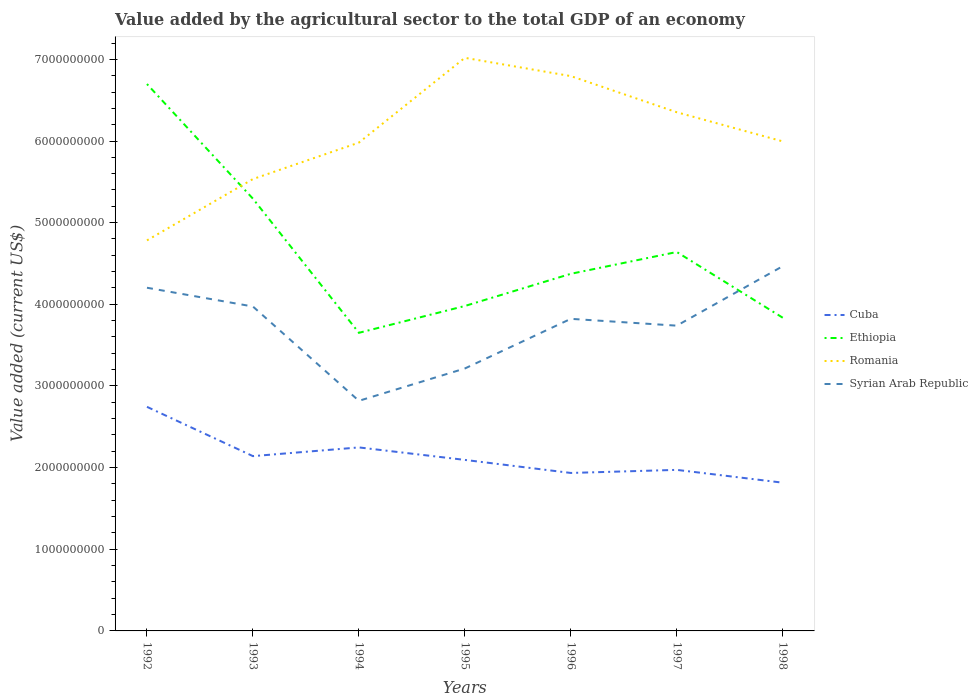How many different coloured lines are there?
Your answer should be compact. 4. Across all years, what is the maximum value added by the agricultural sector to the total GDP in Syrian Arab Republic?
Offer a terse response. 2.82e+09. In which year was the value added by the agricultural sector to the total GDP in Syrian Arab Republic maximum?
Make the answer very short. 1994. What is the total value added by the agricultural sector to the total GDP in Syrian Arab Republic in the graph?
Provide a succinct answer. -5.25e+08. What is the difference between the highest and the second highest value added by the agricultural sector to the total GDP in Syrian Arab Republic?
Provide a succinct answer. 1.65e+09. Is the value added by the agricultural sector to the total GDP in Ethiopia strictly greater than the value added by the agricultural sector to the total GDP in Romania over the years?
Provide a succinct answer. No. What is the difference between two consecutive major ticks on the Y-axis?
Ensure brevity in your answer.  1.00e+09. Does the graph contain grids?
Keep it short and to the point. No. Where does the legend appear in the graph?
Your answer should be compact. Center right. How are the legend labels stacked?
Give a very brief answer. Vertical. What is the title of the graph?
Make the answer very short. Value added by the agricultural sector to the total GDP of an economy. Does "Jamaica" appear as one of the legend labels in the graph?
Give a very brief answer. No. What is the label or title of the X-axis?
Your response must be concise. Years. What is the label or title of the Y-axis?
Ensure brevity in your answer.  Value added (current US$). What is the Value added (current US$) of Cuba in 1992?
Your answer should be very brief. 2.74e+09. What is the Value added (current US$) in Ethiopia in 1992?
Offer a very short reply. 6.70e+09. What is the Value added (current US$) of Romania in 1992?
Give a very brief answer. 4.78e+09. What is the Value added (current US$) in Syrian Arab Republic in 1992?
Give a very brief answer. 4.20e+09. What is the Value added (current US$) of Cuba in 1993?
Provide a short and direct response. 2.14e+09. What is the Value added (current US$) in Ethiopia in 1993?
Offer a terse response. 5.29e+09. What is the Value added (current US$) of Romania in 1993?
Keep it short and to the point. 5.53e+09. What is the Value added (current US$) of Syrian Arab Republic in 1993?
Provide a succinct answer. 3.97e+09. What is the Value added (current US$) of Cuba in 1994?
Offer a terse response. 2.25e+09. What is the Value added (current US$) of Ethiopia in 1994?
Provide a short and direct response. 3.65e+09. What is the Value added (current US$) in Romania in 1994?
Your response must be concise. 5.98e+09. What is the Value added (current US$) of Syrian Arab Republic in 1994?
Offer a very short reply. 2.82e+09. What is the Value added (current US$) in Cuba in 1995?
Your answer should be compact. 2.09e+09. What is the Value added (current US$) of Ethiopia in 1995?
Your answer should be compact. 3.98e+09. What is the Value added (current US$) of Romania in 1995?
Provide a succinct answer. 7.02e+09. What is the Value added (current US$) in Syrian Arab Republic in 1995?
Your response must be concise. 3.21e+09. What is the Value added (current US$) of Cuba in 1996?
Offer a terse response. 1.93e+09. What is the Value added (current US$) of Ethiopia in 1996?
Provide a succinct answer. 4.37e+09. What is the Value added (current US$) in Romania in 1996?
Offer a very short reply. 6.80e+09. What is the Value added (current US$) of Syrian Arab Republic in 1996?
Your answer should be very brief. 3.82e+09. What is the Value added (current US$) in Cuba in 1997?
Ensure brevity in your answer.  1.97e+09. What is the Value added (current US$) in Ethiopia in 1997?
Give a very brief answer. 4.64e+09. What is the Value added (current US$) in Romania in 1997?
Ensure brevity in your answer.  6.35e+09. What is the Value added (current US$) of Syrian Arab Republic in 1997?
Offer a terse response. 3.74e+09. What is the Value added (current US$) of Cuba in 1998?
Your answer should be very brief. 1.82e+09. What is the Value added (current US$) in Ethiopia in 1998?
Make the answer very short. 3.84e+09. What is the Value added (current US$) of Romania in 1998?
Provide a succinct answer. 6.00e+09. What is the Value added (current US$) of Syrian Arab Republic in 1998?
Ensure brevity in your answer.  4.47e+09. Across all years, what is the maximum Value added (current US$) of Cuba?
Provide a short and direct response. 2.74e+09. Across all years, what is the maximum Value added (current US$) in Ethiopia?
Give a very brief answer. 6.70e+09. Across all years, what is the maximum Value added (current US$) in Romania?
Provide a succinct answer. 7.02e+09. Across all years, what is the maximum Value added (current US$) of Syrian Arab Republic?
Make the answer very short. 4.47e+09. Across all years, what is the minimum Value added (current US$) in Cuba?
Your answer should be compact. 1.82e+09. Across all years, what is the minimum Value added (current US$) of Ethiopia?
Ensure brevity in your answer.  3.65e+09. Across all years, what is the minimum Value added (current US$) of Romania?
Make the answer very short. 4.78e+09. Across all years, what is the minimum Value added (current US$) in Syrian Arab Republic?
Give a very brief answer. 2.82e+09. What is the total Value added (current US$) in Cuba in the graph?
Provide a succinct answer. 1.49e+1. What is the total Value added (current US$) of Ethiopia in the graph?
Make the answer very short. 3.25e+1. What is the total Value added (current US$) in Romania in the graph?
Your answer should be very brief. 4.25e+1. What is the total Value added (current US$) of Syrian Arab Republic in the graph?
Your answer should be compact. 2.62e+1. What is the difference between the Value added (current US$) of Cuba in 1992 and that in 1993?
Provide a succinct answer. 6.04e+08. What is the difference between the Value added (current US$) of Ethiopia in 1992 and that in 1993?
Give a very brief answer. 1.40e+09. What is the difference between the Value added (current US$) in Romania in 1992 and that in 1993?
Give a very brief answer. -7.51e+08. What is the difference between the Value added (current US$) in Syrian Arab Republic in 1992 and that in 1993?
Offer a very short reply. 2.30e+08. What is the difference between the Value added (current US$) in Cuba in 1992 and that in 1994?
Keep it short and to the point. 4.97e+08. What is the difference between the Value added (current US$) of Ethiopia in 1992 and that in 1994?
Provide a short and direct response. 3.05e+09. What is the difference between the Value added (current US$) of Romania in 1992 and that in 1994?
Give a very brief answer. -1.20e+09. What is the difference between the Value added (current US$) in Syrian Arab Republic in 1992 and that in 1994?
Provide a short and direct response. 1.38e+09. What is the difference between the Value added (current US$) in Cuba in 1992 and that in 1995?
Provide a succinct answer. 6.50e+08. What is the difference between the Value added (current US$) of Ethiopia in 1992 and that in 1995?
Your response must be concise. 2.72e+09. What is the difference between the Value added (current US$) in Romania in 1992 and that in 1995?
Keep it short and to the point. -2.24e+09. What is the difference between the Value added (current US$) in Syrian Arab Republic in 1992 and that in 1995?
Provide a short and direct response. 9.89e+08. What is the difference between the Value added (current US$) in Cuba in 1992 and that in 1996?
Provide a succinct answer. 8.10e+08. What is the difference between the Value added (current US$) in Ethiopia in 1992 and that in 1996?
Your answer should be compact. 2.32e+09. What is the difference between the Value added (current US$) of Romania in 1992 and that in 1996?
Give a very brief answer. -2.01e+09. What is the difference between the Value added (current US$) in Syrian Arab Republic in 1992 and that in 1996?
Your response must be concise. 3.81e+08. What is the difference between the Value added (current US$) in Cuba in 1992 and that in 1997?
Your answer should be very brief. 7.72e+08. What is the difference between the Value added (current US$) of Ethiopia in 1992 and that in 1997?
Provide a short and direct response. 2.06e+09. What is the difference between the Value added (current US$) of Romania in 1992 and that in 1997?
Your response must be concise. -1.57e+09. What is the difference between the Value added (current US$) of Syrian Arab Republic in 1992 and that in 1997?
Offer a very short reply. 4.64e+08. What is the difference between the Value added (current US$) of Cuba in 1992 and that in 1998?
Keep it short and to the point. 9.29e+08. What is the difference between the Value added (current US$) of Ethiopia in 1992 and that in 1998?
Ensure brevity in your answer.  2.86e+09. What is the difference between the Value added (current US$) of Romania in 1992 and that in 1998?
Provide a succinct answer. -1.21e+09. What is the difference between the Value added (current US$) of Syrian Arab Republic in 1992 and that in 1998?
Keep it short and to the point. -2.64e+08. What is the difference between the Value added (current US$) of Cuba in 1993 and that in 1994?
Provide a succinct answer. -1.07e+08. What is the difference between the Value added (current US$) of Ethiopia in 1993 and that in 1994?
Offer a terse response. 1.64e+09. What is the difference between the Value added (current US$) of Romania in 1993 and that in 1994?
Provide a short and direct response. -4.46e+08. What is the difference between the Value added (current US$) of Syrian Arab Republic in 1993 and that in 1994?
Keep it short and to the point. 1.15e+09. What is the difference between the Value added (current US$) in Cuba in 1993 and that in 1995?
Ensure brevity in your answer.  4.63e+07. What is the difference between the Value added (current US$) in Ethiopia in 1993 and that in 1995?
Offer a terse response. 1.31e+09. What is the difference between the Value added (current US$) in Romania in 1993 and that in 1995?
Your answer should be very brief. -1.48e+09. What is the difference between the Value added (current US$) in Syrian Arab Republic in 1993 and that in 1995?
Ensure brevity in your answer.  7.59e+08. What is the difference between the Value added (current US$) of Cuba in 1993 and that in 1996?
Give a very brief answer. 2.06e+08. What is the difference between the Value added (current US$) of Ethiopia in 1993 and that in 1996?
Provide a succinct answer. 9.20e+08. What is the difference between the Value added (current US$) in Romania in 1993 and that in 1996?
Offer a very short reply. -1.26e+09. What is the difference between the Value added (current US$) in Syrian Arab Republic in 1993 and that in 1996?
Make the answer very short. 1.51e+08. What is the difference between the Value added (current US$) in Cuba in 1993 and that in 1997?
Make the answer very short. 1.68e+08. What is the difference between the Value added (current US$) in Ethiopia in 1993 and that in 1997?
Make the answer very short. 6.53e+08. What is the difference between the Value added (current US$) of Romania in 1993 and that in 1997?
Make the answer very short. -8.18e+08. What is the difference between the Value added (current US$) of Syrian Arab Republic in 1993 and that in 1997?
Your answer should be compact. 2.34e+08. What is the difference between the Value added (current US$) of Cuba in 1993 and that in 1998?
Your response must be concise. 3.25e+08. What is the difference between the Value added (current US$) of Ethiopia in 1993 and that in 1998?
Offer a terse response. 1.46e+09. What is the difference between the Value added (current US$) of Romania in 1993 and that in 1998?
Offer a terse response. -4.61e+08. What is the difference between the Value added (current US$) of Syrian Arab Republic in 1993 and that in 1998?
Make the answer very short. -4.94e+08. What is the difference between the Value added (current US$) in Cuba in 1994 and that in 1995?
Keep it short and to the point. 1.53e+08. What is the difference between the Value added (current US$) in Ethiopia in 1994 and that in 1995?
Give a very brief answer. -3.29e+08. What is the difference between the Value added (current US$) in Romania in 1994 and that in 1995?
Offer a very short reply. -1.04e+09. What is the difference between the Value added (current US$) in Syrian Arab Republic in 1994 and that in 1995?
Make the answer very short. -3.96e+08. What is the difference between the Value added (current US$) in Cuba in 1994 and that in 1996?
Keep it short and to the point. 3.13e+08. What is the difference between the Value added (current US$) of Ethiopia in 1994 and that in 1996?
Your response must be concise. -7.23e+08. What is the difference between the Value added (current US$) in Romania in 1994 and that in 1996?
Offer a terse response. -8.15e+08. What is the difference between the Value added (current US$) of Syrian Arab Republic in 1994 and that in 1996?
Make the answer very short. -1.00e+09. What is the difference between the Value added (current US$) in Cuba in 1994 and that in 1997?
Your answer should be very brief. 2.75e+08. What is the difference between the Value added (current US$) in Ethiopia in 1994 and that in 1997?
Your answer should be very brief. -9.90e+08. What is the difference between the Value added (current US$) in Romania in 1994 and that in 1997?
Offer a terse response. -3.72e+08. What is the difference between the Value added (current US$) in Syrian Arab Republic in 1994 and that in 1997?
Offer a terse response. -9.20e+08. What is the difference between the Value added (current US$) in Cuba in 1994 and that in 1998?
Your answer should be very brief. 4.32e+08. What is the difference between the Value added (current US$) in Ethiopia in 1994 and that in 1998?
Your answer should be very brief. -1.85e+08. What is the difference between the Value added (current US$) in Romania in 1994 and that in 1998?
Ensure brevity in your answer.  -1.50e+07. What is the difference between the Value added (current US$) of Syrian Arab Republic in 1994 and that in 1998?
Offer a terse response. -1.65e+09. What is the difference between the Value added (current US$) of Cuba in 1995 and that in 1996?
Your answer should be compact. 1.60e+08. What is the difference between the Value added (current US$) in Ethiopia in 1995 and that in 1996?
Keep it short and to the point. -3.94e+08. What is the difference between the Value added (current US$) of Romania in 1995 and that in 1996?
Your answer should be very brief. 2.24e+08. What is the difference between the Value added (current US$) of Syrian Arab Republic in 1995 and that in 1996?
Offer a terse response. -6.08e+08. What is the difference between the Value added (current US$) of Cuba in 1995 and that in 1997?
Your answer should be very brief. 1.22e+08. What is the difference between the Value added (current US$) of Ethiopia in 1995 and that in 1997?
Offer a terse response. -6.61e+08. What is the difference between the Value added (current US$) of Romania in 1995 and that in 1997?
Provide a short and direct response. 6.67e+08. What is the difference between the Value added (current US$) of Syrian Arab Republic in 1995 and that in 1997?
Give a very brief answer. -5.25e+08. What is the difference between the Value added (current US$) in Cuba in 1995 and that in 1998?
Make the answer very short. 2.79e+08. What is the difference between the Value added (current US$) in Ethiopia in 1995 and that in 1998?
Your response must be concise. 1.44e+08. What is the difference between the Value added (current US$) of Romania in 1995 and that in 1998?
Ensure brevity in your answer.  1.02e+09. What is the difference between the Value added (current US$) in Syrian Arab Republic in 1995 and that in 1998?
Your answer should be very brief. -1.25e+09. What is the difference between the Value added (current US$) in Cuba in 1996 and that in 1997?
Ensure brevity in your answer.  -3.78e+07. What is the difference between the Value added (current US$) of Ethiopia in 1996 and that in 1997?
Offer a very short reply. -2.67e+08. What is the difference between the Value added (current US$) in Romania in 1996 and that in 1997?
Keep it short and to the point. 4.43e+08. What is the difference between the Value added (current US$) of Syrian Arab Republic in 1996 and that in 1997?
Your answer should be very brief. 8.35e+07. What is the difference between the Value added (current US$) in Cuba in 1996 and that in 1998?
Offer a terse response. 1.19e+08. What is the difference between the Value added (current US$) in Ethiopia in 1996 and that in 1998?
Your response must be concise. 5.38e+08. What is the difference between the Value added (current US$) in Romania in 1996 and that in 1998?
Your answer should be very brief. 8.00e+08. What is the difference between the Value added (current US$) of Syrian Arab Republic in 1996 and that in 1998?
Give a very brief answer. -6.45e+08. What is the difference between the Value added (current US$) in Cuba in 1997 and that in 1998?
Your answer should be compact. 1.57e+08. What is the difference between the Value added (current US$) of Ethiopia in 1997 and that in 1998?
Give a very brief answer. 8.05e+08. What is the difference between the Value added (current US$) of Romania in 1997 and that in 1998?
Keep it short and to the point. 3.57e+08. What is the difference between the Value added (current US$) in Syrian Arab Republic in 1997 and that in 1998?
Provide a short and direct response. -7.28e+08. What is the difference between the Value added (current US$) in Cuba in 1992 and the Value added (current US$) in Ethiopia in 1993?
Your answer should be compact. -2.55e+09. What is the difference between the Value added (current US$) in Cuba in 1992 and the Value added (current US$) in Romania in 1993?
Provide a short and direct response. -2.79e+09. What is the difference between the Value added (current US$) in Cuba in 1992 and the Value added (current US$) in Syrian Arab Republic in 1993?
Ensure brevity in your answer.  -1.23e+09. What is the difference between the Value added (current US$) in Ethiopia in 1992 and the Value added (current US$) in Romania in 1993?
Your response must be concise. 1.16e+09. What is the difference between the Value added (current US$) of Ethiopia in 1992 and the Value added (current US$) of Syrian Arab Republic in 1993?
Offer a very short reply. 2.72e+09. What is the difference between the Value added (current US$) in Romania in 1992 and the Value added (current US$) in Syrian Arab Republic in 1993?
Offer a very short reply. 8.10e+08. What is the difference between the Value added (current US$) in Cuba in 1992 and the Value added (current US$) in Ethiopia in 1994?
Offer a terse response. -9.06e+08. What is the difference between the Value added (current US$) in Cuba in 1992 and the Value added (current US$) in Romania in 1994?
Your response must be concise. -3.24e+09. What is the difference between the Value added (current US$) in Cuba in 1992 and the Value added (current US$) in Syrian Arab Republic in 1994?
Your answer should be very brief. -7.36e+07. What is the difference between the Value added (current US$) of Ethiopia in 1992 and the Value added (current US$) of Romania in 1994?
Provide a short and direct response. 7.17e+08. What is the difference between the Value added (current US$) in Ethiopia in 1992 and the Value added (current US$) in Syrian Arab Republic in 1994?
Keep it short and to the point. 3.88e+09. What is the difference between the Value added (current US$) of Romania in 1992 and the Value added (current US$) of Syrian Arab Republic in 1994?
Your answer should be compact. 1.96e+09. What is the difference between the Value added (current US$) in Cuba in 1992 and the Value added (current US$) in Ethiopia in 1995?
Provide a short and direct response. -1.23e+09. What is the difference between the Value added (current US$) in Cuba in 1992 and the Value added (current US$) in Romania in 1995?
Provide a succinct answer. -4.27e+09. What is the difference between the Value added (current US$) in Cuba in 1992 and the Value added (current US$) in Syrian Arab Republic in 1995?
Ensure brevity in your answer.  -4.70e+08. What is the difference between the Value added (current US$) of Ethiopia in 1992 and the Value added (current US$) of Romania in 1995?
Offer a terse response. -3.21e+08. What is the difference between the Value added (current US$) of Ethiopia in 1992 and the Value added (current US$) of Syrian Arab Republic in 1995?
Your answer should be very brief. 3.48e+09. What is the difference between the Value added (current US$) in Romania in 1992 and the Value added (current US$) in Syrian Arab Republic in 1995?
Provide a succinct answer. 1.57e+09. What is the difference between the Value added (current US$) in Cuba in 1992 and the Value added (current US$) in Ethiopia in 1996?
Keep it short and to the point. -1.63e+09. What is the difference between the Value added (current US$) in Cuba in 1992 and the Value added (current US$) in Romania in 1996?
Give a very brief answer. -4.05e+09. What is the difference between the Value added (current US$) in Cuba in 1992 and the Value added (current US$) in Syrian Arab Republic in 1996?
Give a very brief answer. -1.08e+09. What is the difference between the Value added (current US$) of Ethiopia in 1992 and the Value added (current US$) of Romania in 1996?
Your answer should be very brief. -9.73e+07. What is the difference between the Value added (current US$) of Ethiopia in 1992 and the Value added (current US$) of Syrian Arab Republic in 1996?
Your answer should be compact. 2.88e+09. What is the difference between the Value added (current US$) of Romania in 1992 and the Value added (current US$) of Syrian Arab Republic in 1996?
Your answer should be very brief. 9.61e+08. What is the difference between the Value added (current US$) in Cuba in 1992 and the Value added (current US$) in Ethiopia in 1997?
Keep it short and to the point. -1.90e+09. What is the difference between the Value added (current US$) in Cuba in 1992 and the Value added (current US$) in Romania in 1997?
Your answer should be very brief. -3.61e+09. What is the difference between the Value added (current US$) of Cuba in 1992 and the Value added (current US$) of Syrian Arab Republic in 1997?
Offer a terse response. -9.94e+08. What is the difference between the Value added (current US$) of Ethiopia in 1992 and the Value added (current US$) of Romania in 1997?
Your response must be concise. 3.46e+08. What is the difference between the Value added (current US$) in Ethiopia in 1992 and the Value added (current US$) in Syrian Arab Republic in 1997?
Make the answer very short. 2.96e+09. What is the difference between the Value added (current US$) of Romania in 1992 and the Value added (current US$) of Syrian Arab Republic in 1997?
Give a very brief answer. 1.04e+09. What is the difference between the Value added (current US$) in Cuba in 1992 and the Value added (current US$) in Ethiopia in 1998?
Provide a succinct answer. -1.09e+09. What is the difference between the Value added (current US$) in Cuba in 1992 and the Value added (current US$) in Romania in 1998?
Offer a terse response. -3.25e+09. What is the difference between the Value added (current US$) of Cuba in 1992 and the Value added (current US$) of Syrian Arab Republic in 1998?
Keep it short and to the point. -1.72e+09. What is the difference between the Value added (current US$) of Ethiopia in 1992 and the Value added (current US$) of Romania in 1998?
Your response must be concise. 7.02e+08. What is the difference between the Value added (current US$) of Ethiopia in 1992 and the Value added (current US$) of Syrian Arab Republic in 1998?
Make the answer very short. 2.23e+09. What is the difference between the Value added (current US$) in Romania in 1992 and the Value added (current US$) in Syrian Arab Republic in 1998?
Ensure brevity in your answer.  3.16e+08. What is the difference between the Value added (current US$) in Cuba in 1993 and the Value added (current US$) in Ethiopia in 1994?
Offer a very short reply. -1.51e+09. What is the difference between the Value added (current US$) of Cuba in 1993 and the Value added (current US$) of Romania in 1994?
Give a very brief answer. -3.84e+09. What is the difference between the Value added (current US$) in Cuba in 1993 and the Value added (current US$) in Syrian Arab Republic in 1994?
Make the answer very short. -6.77e+08. What is the difference between the Value added (current US$) of Ethiopia in 1993 and the Value added (current US$) of Romania in 1994?
Provide a short and direct response. -6.87e+08. What is the difference between the Value added (current US$) of Ethiopia in 1993 and the Value added (current US$) of Syrian Arab Republic in 1994?
Your answer should be very brief. 2.48e+09. What is the difference between the Value added (current US$) in Romania in 1993 and the Value added (current US$) in Syrian Arab Republic in 1994?
Give a very brief answer. 2.72e+09. What is the difference between the Value added (current US$) in Cuba in 1993 and the Value added (current US$) in Ethiopia in 1995?
Your answer should be very brief. -1.84e+09. What is the difference between the Value added (current US$) in Cuba in 1993 and the Value added (current US$) in Romania in 1995?
Give a very brief answer. -4.88e+09. What is the difference between the Value added (current US$) in Cuba in 1993 and the Value added (current US$) in Syrian Arab Republic in 1995?
Give a very brief answer. -1.07e+09. What is the difference between the Value added (current US$) in Ethiopia in 1993 and the Value added (current US$) in Romania in 1995?
Your response must be concise. -1.73e+09. What is the difference between the Value added (current US$) of Ethiopia in 1993 and the Value added (current US$) of Syrian Arab Republic in 1995?
Provide a short and direct response. 2.08e+09. What is the difference between the Value added (current US$) in Romania in 1993 and the Value added (current US$) in Syrian Arab Republic in 1995?
Your response must be concise. 2.32e+09. What is the difference between the Value added (current US$) in Cuba in 1993 and the Value added (current US$) in Ethiopia in 1996?
Your response must be concise. -2.23e+09. What is the difference between the Value added (current US$) in Cuba in 1993 and the Value added (current US$) in Romania in 1996?
Offer a very short reply. -4.65e+09. What is the difference between the Value added (current US$) in Cuba in 1993 and the Value added (current US$) in Syrian Arab Republic in 1996?
Give a very brief answer. -1.68e+09. What is the difference between the Value added (current US$) of Ethiopia in 1993 and the Value added (current US$) of Romania in 1996?
Your answer should be very brief. -1.50e+09. What is the difference between the Value added (current US$) of Ethiopia in 1993 and the Value added (current US$) of Syrian Arab Republic in 1996?
Provide a succinct answer. 1.47e+09. What is the difference between the Value added (current US$) in Romania in 1993 and the Value added (current US$) in Syrian Arab Republic in 1996?
Keep it short and to the point. 1.71e+09. What is the difference between the Value added (current US$) of Cuba in 1993 and the Value added (current US$) of Ethiopia in 1997?
Your response must be concise. -2.50e+09. What is the difference between the Value added (current US$) in Cuba in 1993 and the Value added (current US$) in Romania in 1997?
Your response must be concise. -4.21e+09. What is the difference between the Value added (current US$) of Cuba in 1993 and the Value added (current US$) of Syrian Arab Republic in 1997?
Make the answer very short. -1.60e+09. What is the difference between the Value added (current US$) in Ethiopia in 1993 and the Value added (current US$) in Romania in 1997?
Ensure brevity in your answer.  -1.06e+09. What is the difference between the Value added (current US$) in Ethiopia in 1993 and the Value added (current US$) in Syrian Arab Republic in 1997?
Your response must be concise. 1.56e+09. What is the difference between the Value added (current US$) of Romania in 1993 and the Value added (current US$) of Syrian Arab Republic in 1997?
Your response must be concise. 1.80e+09. What is the difference between the Value added (current US$) in Cuba in 1993 and the Value added (current US$) in Ethiopia in 1998?
Ensure brevity in your answer.  -1.69e+09. What is the difference between the Value added (current US$) of Cuba in 1993 and the Value added (current US$) of Romania in 1998?
Provide a short and direct response. -3.85e+09. What is the difference between the Value added (current US$) of Cuba in 1993 and the Value added (current US$) of Syrian Arab Republic in 1998?
Your answer should be very brief. -2.33e+09. What is the difference between the Value added (current US$) of Ethiopia in 1993 and the Value added (current US$) of Romania in 1998?
Make the answer very short. -7.02e+08. What is the difference between the Value added (current US$) in Ethiopia in 1993 and the Value added (current US$) in Syrian Arab Republic in 1998?
Keep it short and to the point. 8.27e+08. What is the difference between the Value added (current US$) of Romania in 1993 and the Value added (current US$) of Syrian Arab Republic in 1998?
Your answer should be very brief. 1.07e+09. What is the difference between the Value added (current US$) of Cuba in 1994 and the Value added (current US$) of Ethiopia in 1995?
Your answer should be compact. -1.73e+09. What is the difference between the Value added (current US$) of Cuba in 1994 and the Value added (current US$) of Romania in 1995?
Make the answer very short. -4.77e+09. What is the difference between the Value added (current US$) of Cuba in 1994 and the Value added (current US$) of Syrian Arab Republic in 1995?
Your answer should be compact. -9.67e+08. What is the difference between the Value added (current US$) of Ethiopia in 1994 and the Value added (current US$) of Romania in 1995?
Offer a terse response. -3.37e+09. What is the difference between the Value added (current US$) of Ethiopia in 1994 and the Value added (current US$) of Syrian Arab Republic in 1995?
Provide a short and direct response. 4.37e+08. What is the difference between the Value added (current US$) in Romania in 1994 and the Value added (current US$) in Syrian Arab Republic in 1995?
Make the answer very short. 2.77e+09. What is the difference between the Value added (current US$) of Cuba in 1994 and the Value added (current US$) of Ethiopia in 1996?
Provide a succinct answer. -2.13e+09. What is the difference between the Value added (current US$) in Cuba in 1994 and the Value added (current US$) in Romania in 1996?
Your answer should be compact. -4.55e+09. What is the difference between the Value added (current US$) in Cuba in 1994 and the Value added (current US$) in Syrian Arab Republic in 1996?
Keep it short and to the point. -1.57e+09. What is the difference between the Value added (current US$) in Ethiopia in 1994 and the Value added (current US$) in Romania in 1996?
Your response must be concise. -3.14e+09. What is the difference between the Value added (current US$) in Ethiopia in 1994 and the Value added (current US$) in Syrian Arab Republic in 1996?
Keep it short and to the point. -1.71e+08. What is the difference between the Value added (current US$) of Romania in 1994 and the Value added (current US$) of Syrian Arab Republic in 1996?
Your answer should be compact. 2.16e+09. What is the difference between the Value added (current US$) of Cuba in 1994 and the Value added (current US$) of Ethiopia in 1997?
Provide a short and direct response. -2.39e+09. What is the difference between the Value added (current US$) of Cuba in 1994 and the Value added (current US$) of Romania in 1997?
Provide a succinct answer. -4.10e+09. What is the difference between the Value added (current US$) of Cuba in 1994 and the Value added (current US$) of Syrian Arab Republic in 1997?
Your answer should be very brief. -1.49e+09. What is the difference between the Value added (current US$) in Ethiopia in 1994 and the Value added (current US$) in Romania in 1997?
Ensure brevity in your answer.  -2.70e+09. What is the difference between the Value added (current US$) of Ethiopia in 1994 and the Value added (current US$) of Syrian Arab Republic in 1997?
Give a very brief answer. -8.76e+07. What is the difference between the Value added (current US$) in Romania in 1994 and the Value added (current US$) in Syrian Arab Republic in 1997?
Your response must be concise. 2.24e+09. What is the difference between the Value added (current US$) in Cuba in 1994 and the Value added (current US$) in Ethiopia in 1998?
Offer a very short reply. -1.59e+09. What is the difference between the Value added (current US$) in Cuba in 1994 and the Value added (current US$) in Romania in 1998?
Offer a terse response. -3.75e+09. What is the difference between the Value added (current US$) of Cuba in 1994 and the Value added (current US$) of Syrian Arab Republic in 1998?
Offer a very short reply. -2.22e+09. What is the difference between the Value added (current US$) in Ethiopia in 1994 and the Value added (current US$) in Romania in 1998?
Provide a succinct answer. -2.34e+09. What is the difference between the Value added (current US$) of Ethiopia in 1994 and the Value added (current US$) of Syrian Arab Republic in 1998?
Make the answer very short. -8.16e+08. What is the difference between the Value added (current US$) in Romania in 1994 and the Value added (current US$) in Syrian Arab Republic in 1998?
Ensure brevity in your answer.  1.51e+09. What is the difference between the Value added (current US$) of Cuba in 1995 and the Value added (current US$) of Ethiopia in 1996?
Ensure brevity in your answer.  -2.28e+09. What is the difference between the Value added (current US$) of Cuba in 1995 and the Value added (current US$) of Romania in 1996?
Your answer should be very brief. -4.70e+09. What is the difference between the Value added (current US$) of Cuba in 1995 and the Value added (current US$) of Syrian Arab Republic in 1996?
Your response must be concise. -1.73e+09. What is the difference between the Value added (current US$) of Ethiopia in 1995 and the Value added (current US$) of Romania in 1996?
Give a very brief answer. -2.82e+09. What is the difference between the Value added (current US$) in Ethiopia in 1995 and the Value added (current US$) in Syrian Arab Republic in 1996?
Give a very brief answer. 1.57e+08. What is the difference between the Value added (current US$) in Romania in 1995 and the Value added (current US$) in Syrian Arab Republic in 1996?
Keep it short and to the point. 3.20e+09. What is the difference between the Value added (current US$) in Cuba in 1995 and the Value added (current US$) in Ethiopia in 1997?
Offer a terse response. -2.55e+09. What is the difference between the Value added (current US$) in Cuba in 1995 and the Value added (current US$) in Romania in 1997?
Keep it short and to the point. -4.26e+09. What is the difference between the Value added (current US$) of Cuba in 1995 and the Value added (current US$) of Syrian Arab Republic in 1997?
Ensure brevity in your answer.  -1.64e+09. What is the difference between the Value added (current US$) in Ethiopia in 1995 and the Value added (current US$) in Romania in 1997?
Your response must be concise. -2.37e+09. What is the difference between the Value added (current US$) in Ethiopia in 1995 and the Value added (current US$) in Syrian Arab Republic in 1997?
Your answer should be very brief. 2.41e+08. What is the difference between the Value added (current US$) in Romania in 1995 and the Value added (current US$) in Syrian Arab Republic in 1997?
Provide a succinct answer. 3.28e+09. What is the difference between the Value added (current US$) in Cuba in 1995 and the Value added (current US$) in Ethiopia in 1998?
Keep it short and to the point. -1.74e+09. What is the difference between the Value added (current US$) of Cuba in 1995 and the Value added (current US$) of Romania in 1998?
Keep it short and to the point. -3.90e+09. What is the difference between the Value added (current US$) in Cuba in 1995 and the Value added (current US$) in Syrian Arab Republic in 1998?
Keep it short and to the point. -2.37e+09. What is the difference between the Value added (current US$) of Ethiopia in 1995 and the Value added (current US$) of Romania in 1998?
Keep it short and to the point. -2.02e+09. What is the difference between the Value added (current US$) in Ethiopia in 1995 and the Value added (current US$) in Syrian Arab Republic in 1998?
Give a very brief answer. -4.87e+08. What is the difference between the Value added (current US$) of Romania in 1995 and the Value added (current US$) of Syrian Arab Republic in 1998?
Ensure brevity in your answer.  2.55e+09. What is the difference between the Value added (current US$) in Cuba in 1996 and the Value added (current US$) in Ethiopia in 1997?
Give a very brief answer. -2.71e+09. What is the difference between the Value added (current US$) of Cuba in 1996 and the Value added (current US$) of Romania in 1997?
Give a very brief answer. -4.42e+09. What is the difference between the Value added (current US$) of Cuba in 1996 and the Value added (current US$) of Syrian Arab Republic in 1997?
Offer a terse response. -1.80e+09. What is the difference between the Value added (current US$) in Ethiopia in 1996 and the Value added (current US$) in Romania in 1997?
Your answer should be very brief. -1.98e+09. What is the difference between the Value added (current US$) of Ethiopia in 1996 and the Value added (current US$) of Syrian Arab Republic in 1997?
Your answer should be compact. 6.35e+08. What is the difference between the Value added (current US$) in Romania in 1996 and the Value added (current US$) in Syrian Arab Republic in 1997?
Your answer should be compact. 3.06e+09. What is the difference between the Value added (current US$) of Cuba in 1996 and the Value added (current US$) of Ethiopia in 1998?
Provide a succinct answer. -1.90e+09. What is the difference between the Value added (current US$) of Cuba in 1996 and the Value added (current US$) of Romania in 1998?
Give a very brief answer. -4.06e+09. What is the difference between the Value added (current US$) in Cuba in 1996 and the Value added (current US$) in Syrian Arab Republic in 1998?
Your response must be concise. -2.53e+09. What is the difference between the Value added (current US$) of Ethiopia in 1996 and the Value added (current US$) of Romania in 1998?
Your response must be concise. -1.62e+09. What is the difference between the Value added (current US$) of Ethiopia in 1996 and the Value added (current US$) of Syrian Arab Republic in 1998?
Your response must be concise. -9.34e+07. What is the difference between the Value added (current US$) in Romania in 1996 and the Value added (current US$) in Syrian Arab Republic in 1998?
Keep it short and to the point. 2.33e+09. What is the difference between the Value added (current US$) in Cuba in 1997 and the Value added (current US$) in Ethiopia in 1998?
Your answer should be compact. -1.86e+09. What is the difference between the Value added (current US$) of Cuba in 1997 and the Value added (current US$) of Romania in 1998?
Provide a short and direct response. -4.02e+09. What is the difference between the Value added (current US$) of Cuba in 1997 and the Value added (current US$) of Syrian Arab Republic in 1998?
Keep it short and to the point. -2.49e+09. What is the difference between the Value added (current US$) of Ethiopia in 1997 and the Value added (current US$) of Romania in 1998?
Ensure brevity in your answer.  -1.35e+09. What is the difference between the Value added (current US$) in Ethiopia in 1997 and the Value added (current US$) in Syrian Arab Republic in 1998?
Make the answer very short. 1.74e+08. What is the difference between the Value added (current US$) of Romania in 1997 and the Value added (current US$) of Syrian Arab Republic in 1998?
Your response must be concise. 1.89e+09. What is the average Value added (current US$) of Cuba per year?
Make the answer very short. 2.14e+09. What is the average Value added (current US$) of Ethiopia per year?
Provide a short and direct response. 4.64e+09. What is the average Value added (current US$) in Romania per year?
Ensure brevity in your answer.  6.07e+09. What is the average Value added (current US$) of Syrian Arab Republic per year?
Give a very brief answer. 3.75e+09. In the year 1992, what is the difference between the Value added (current US$) in Cuba and Value added (current US$) in Ethiopia?
Provide a succinct answer. -3.95e+09. In the year 1992, what is the difference between the Value added (current US$) in Cuba and Value added (current US$) in Romania?
Ensure brevity in your answer.  -2.04e+09. In the year 1992, what is the difference between the Value added (current US$) of Cuba and Value added (current US$) of Syrian Arab Republic?
Keep it short and to the point. -1.46e+09. In the year 1992, what is the difference between the Value added (current US$) in Ethiopia and Value added (current US$) in Romania?
Give a very brief answer. 1.91e+09. In the year 1992, what is the difference between the Value added (current US$) in Ethiopia and Value added (current US$) in Syrian Arab Republic?
Your answer should be very brief. 2.49e+09. In the year 1992, what is the difference between the Value added (current US$) in Romania and Value added (current US$) in Syrian Arab Republic?
Offer a very short reply. 5.80e+08. In the year 1993, what is the difference between the Value added (current US$) in Cuba and Value added (current US$) in Ethiopia?
Offer a terse response. -3.15e+09. In the year 1993, what is the difference between the Value added (current US$) of Cuba and Value added (current US$) of Romania?
Give a very brief answer. -3.39e+09. In the year 1993, what is the difference between the Value added (current US$) in Cuba and Value added (current US$) in Syrian Arab Republic?
Your answer should be compact. -1.83e+09. In the year 1993, what is the difference between the Value added (current US$) of Ethiopia and Value added (current US$) of Romania?
Ensure brevity in your answer.  -2.40e+08. In the year 1993, what is the difference between the Value added (current US$) in Ethiopia and Value added (current US$) in Syrian Arab Republic?
Offer a very short reply. 1.32e+09. In the year 1993, what is the difference between the Value added (current US$) in Romania and Value added (current US$) in Syrian Arab Republic?
Offer a terse response. 1.56e+09. In the year 1994, what is the difference between the Value added (current US$) in Cuba and Value added (current US$) in Ethiopia?
Give a very brief answer. -1.40e+09. In the year 1994, what is the difference between the Value added (current US$) of Cuba and Value added (current US$) of Romania?
Offer a very short reply. -3.73e+09. In the year 1994, what is the difference between the Value added (current US$) in Cuba and Value added (current US$) in Syrian Arab Republic?
Your response must be concise. -5.71e+08. In the year 1994, what is the difference between the Value added (current US$) in Ethiopia and Value added (current US$) in Romania?
Keep it short and to the point. -2.33e+09. In the year 1994, what is the difference between the Value added (current US$) in Ethiopia and Value added (current US$) in Syrian Arab Republic?
Your response must be concise. 8.33e+08. In the year 1994, what is the difference between the Value added (current US$) in Romania and Value added (current US$) in Syrian Arab Republic?
Offer a very short reply. 3.16e+09. In the year 1995, what is the difference between the Value added (current US$) in Cuba and Value added (current US$) in Ethiopia?
Offer a very short reply. -1.89e+09. In the year 1995, what is the difference between the Value added (current US$) in Cuba and Value added (current US$) in Romania?
Offer a terse response. -4.92e+09. In the year 1995, what is the difference between the Value added (current US$) of Cuba and Value added (current US$) of Syrian Arab Republic?
Ensure brevity in your answer.  -1.12e+09. In the year 1995, what is the difference between the Value added (current US$) of Ethiopia and Value added (current US$) of Romania?
Give a very brief answer. -3.04e+09. In the year 1995, what is the difference between the Value added (current US$) in Ethiopia and Value added (current US$) in Syrian Arab Republic?
Your answer should be very brief. 7.65e+08. In the year 1995, what is the difference between the Value added (current US$) in Romania and Value added (current US$) in Syrian Arab Republic?
Ensure brevity in your answer.  3.80e+09. In the year 1996, what is the difference between the Value added (current US$) in Cuba and Value added (current US$) in Ethiopia?
Your answer should be very brief. -2.44e+09. In the year 1996, what is the difference between the Value added (current US$) of Cuba and Value added (current US$) of Romania?
Make the answer very short. -4.86e+09. In the year 1996, what is the difference between the Value added (current US$) of Cuba and Value added (current US$) of Syrian Arab Republic?
Your response must be concise. -1.89e+09. In the year 1996, what is the difference between the Value added (current US$) in Ethiopia and Value added (current US$) in Romania?
Your answer should be very brief. -2.42e+09. In the year 1996, what is the difference between the Value added (current US$) of Ethiopia and Value added (current US$) of Syrian Arab Republic?
Provide a succinct answer. 5.51e+08. In the year 1996, what is the difference between the Value added (current US$) in Romania and Value added (current US$) in Syrian Arab Republic?
Make the answer very short. 2.97e+09. In the year 1997, what is the difference between the Value added (current US$) in Cuba and Value added (current US$) in Ethiopia?
Your answer should be very brief. -2.67e+09. In the year 1997, what is the difference between the Value added (current US$) in Cuba and Value added (current US$) in Romania?
Your answer should be very brief. -4.38e+09. In the year 1997, what is the difference between the Value added (current US$) of Cuba and Value added (current US$) of Syrian Arab Republic?
Your answer should be compact. -1.77e+09. In the year 1997, what is the difference between the Value added (current US$) in Ethiopia and Value added (current US$) in Romania?
Make the answer very short. -1.71e+09. In the year 1997, what is the difference between the Value added (current US$) of Ethiopia and Value added (current US$) of Syrian Arab Republic?
Your answer should be compact. 9.02e+08. In the year 1997, what is the difference between the Value added (current US$) of Romania and Value added (current US$) of Syrian Arab Republic?
Offer a very short reply. 2.61e+09. In the year 1998, what is the difference between the Value added (current US$) of Cuba and Value added (current US$) of Ethiopia?
Ensure brevity in your answer.  -2.02e+09. In the year 1998, what is the difference between the Value added (current US$) of Cuba and Value added (current US$) of Romania?
Keep it short and to the point. -4.18e+09. In the year 1998, what is the difference between the Value added (current US$) of Cuba and Value added (current US$) of Syrian Arab Republic?
Provide a succinct answer. -2.65e+09. In the year 1998, what is the difference between the Value added (current US$) of Ethiopia and Value added (current US$) of Romania?
Your answer should be compact. -2.16e+09. In the year 1998, what is the difference between the Value added (current US$) of Ethiopia and Value added (current US$) of Syrian Arab Republic?
Provide a short and direct response. -6.31e+08. In the year 1998, what is the difference between the Value added (current US$) in Romania and Value added (current US$) in Syrian Arab Republic?
Provide a short and direct response. 1.53e+09. What is the ratio of the Value added (current US$) in Cuba in 1992 to that in 1993?
Provide a succinct answer. 1.28. What is the ratio of the Value added (current US$) in Ethiopia in 1992 to that in 1993?
Your answer should be compact. 1.27. What is the ratio of the Value added (current US$) of Romania in 1992 to that in 1993?
Give a very brief answer. 0.86. What is the ratio of the Value added (current US$) of Syrian Arab Republic in 1992 to that in 1993?
Make the answer very short. 1.06. What is the ratio of the Value added (current US$) in Cuba in 1992 to that in 1994?
Offer a very short reply. 1.22. What is the ratio of the Value added (current US$) in Ethiopia in 1992 to that in 1994?
Make the answer very short. 1.83. What is the ratio of the Value added (current US$) in Romania in 1992 to that in 1994?
Offer a very short reply. 0.8. What is the ratio of the Value added (current US$) of Syrian Arab Republic in 1992 to that in 1994?
Keep it short and to the point. 1.49. What is the ratio of the Value added (current US$) in Cuba in 1992 to that in 1995?
Provide a short and direct response. 1.31. What is the ratio of the Value added (current US$) of Ethiopia in 1992 to that in 1995?
Make the answer very short. 1.68. What is the ratio of the Value added (current US$) in Romania in 1992 to that in 1995?
Keep it short and to the point. 0.68. What is the ratio of the Value added (current US$) of Syrian Arab Republic in 1992 to that in 1995?
Make the answer very short. 1.31. What is the ratio of the Value added (current US$) in Cuba in 1992 to that in 1996?
Ensure brevity in your answer.  1.42. What is the ratio of the Value added (current US$) of Ethiopia in 1992 to that in 1996?
Keep it short and to the point. 1.53. What is the ratio of the Value added (current US$) of Romania in 1992 to that in 1996?
Provide a short and direct response. 0.7. What is the ratio of the Value added (current US$) in Syrian Arab Republic in 1992 to that in 1996?
Your answer should be compact. 1.1. What is the ratio of the Value added (current US$) of Cuba in 1992 to that in 1997?
Ensure brevity in your answer.  1.39. What is the ratio of the Value added (current US$) of Ethiopia in 1992 to that in 1997?
Give a very brief answer. 1.44. What is the ratio of the Value added (current US$) in Romania in 1992 to that in 1997?
Offer a terse response. 0.75. What is the ratio of the Value added (current US$) in Syrian Arab Republic in 1992 to that in 1997?
Provide a succinct answer. 1.12. What is the ratio of the Value added (current US$) of Cuba in 1992 to that in 1998?
Provide a short and direct response. 1.51. What is the ratio of the Value added (current US$) in Ethiopia in 1992 to that in 1998?
Offer a very short reply. 1.75. What is the ratio of the Value added (current US$) in Romania in 1992 to that in 1998?
Offer a very short reply. 0.8. What is the ratio of the Value added (current US$) of Syrian Arab Republic in 1992 to that in 1998?
Make the answer very short. 0.94. What is the ratio of the Value added (current US$) of Cuba in 1993 to that in 1994?
Provide a succinct answer. 0.95. What is the ratio of the Value added (current US$) of Ethiopia in 1993 to that in 1994?
Ensure brevity in your answer.  1.45. What is the ratio of the Value added (current US$) in Romania in 1993 to that in 1994?
Provide a short and direct response. 0.93. What is the ratio of the Value added (current US$) of Syrian Arab Republic in 1993 to that in 1994?
Offer a terse response. 1.41. What is the ratio of the Value added (current US$) of Cuba in 1993 to that in 1995?
Provide a succinct answer. 1.02. What is the ratio of the Value added (current US$) in Ethiopia in 1993 to that in 1995?
Ensure brevity in your answer.  1.33. What is the ratio of the Value added (current US$) in Romania in 1993 to that in 1995?
Make the answer very short. 0.79. What is the ratio of the Value added (current US$) in Syrian Arab Republic in 1993 to that in 1995?
Keep it short and to the point. 1.24. What is the ratio of the Value added (current US$) of Cuba in 1993 to that in 1996?
Give a very brief answer. 1.11. What is the ratio of the Value added (current US$) of Ethiopia in 1993 to that in 1996?
Your answer should be very brief. 1.21. What is the ratio of the Value added (current US$) of Romania in 1993 to that in 1996?
Ensure brevity in your answer.  0.81. What is the ratio of the Value added (current US$) of Syrian Arab Republic in 1993 to that in 1996?
Your answer should be compact. 1.04. What is the ratio of the Value added (current US$) of Cuba in 1993 to that in 1997?
Keep it short and to the point. 1.09. What is the ratio of the Value added (current US$) in Ethiopia in 1993 to that in 1997?
Give a very brief answer. 1.14. What is the ratio of the Value added (current US$) in Romania in 1993 to that in 1997?
Provide a short and direct response. 0.87. What is the ratio of the Value added (current US$) of Syrian Arab Republic in 1993 to that in 1997?
Your answer should be compact. 1.06. What is the ratio of the Value added (current US$) of Cuba in 1993 to that in 1998?
Your response must be concise. 1.18. What is the ratio of the Value added (current US$) of Ethiopia in 1993 to that in 1998?
Your answer should be compact. 1.38. What is the ratio of the Value added (current US$) of Romania in 1993 to that in 1998?
Your answer should be very brief. 0.92. What is the ratio of the Value added (current US$) of Syrian Arab Republic in 1993 to that in 1998?
Provide a succinct answer. 0.89. What is the ratio of the Value added (current US$) of Cuba in 1994 to that in 1995?
Offer a terse response. 1.07. What is the ratio of the Value added (current US$) in Ethiopia in 1994 to that in 1995?
Your answer should be compact. 0.92. What is the ratio of the Value added (current US$) in Romania in 1994 to that in 1995?
Provide a succinct answer. 0.85. What is the ratio of the Value added (current US$) in Syrian Arab Republic in 1994 to that in 1995?
Provide a succinct answer. 0.88. What is the ratio of the Value added (current US$) in Cuba in 1994 to that in 1996?
Your answer should be compact. 1.16. What is the ratio of the Value added (current US$) in Ethiopia in 1994 to that in 1996?
Provide a short and direct response. 0.83. What is the ratio of the Value added (current US$) in Romania in 1994 to that in 1996?
Keep it short and to the point. 0.88. What is the ratio of the Value added (current US$) of Syrian Arab Republic in 1994 to that in 1996?
Your answer should be very brief. 0.74. What is the ratio of the Value added (current US$) in Cuba in 1994 to that in 1997?
Give a very brief answer. 1.14. What is the ratio of the Value added (current US$) of Ethiopia in 1994 to that in 1997?
Your response must be concise. 0.79. What is the ratio of the Value added (current US$) in Romania in 1994 to that in 1997?
Offer a very short reply. 0.94. What is the ratio of the Value added (current US$) of Syrian Arab Republic in 1994 to that in 1997?
Offer a terse response. 0.75. What is the ratio of the Value added (current US$) of Cuba in 1994 to that in 1998?
Give a very brief answer. 1.24. What is the ratio of the Value added (current US$) of Ethiopia in 1994 to that in 1998?
Offer a very short reply. 0.95. What is the ratio of the Value added (current US$) in Syrian Arab Republic in 1994 to that in 1998?
Offer a terse response. 0.63. What is the ratio of the Value added (current US$) of Cuba in 1995 to that in 1996?
Give a very brief answer. 1.08. What is the ratio of the Value added (current US$) in Ethiopia in 1995 to that in 1996?
Offer a very short reply. 0.91. What is the ratio of the Value added (current US$) in Romania in 1995 to that in 1996?
Keep it short and to the point. 1.03. What is the ratio of the Value added (current US$) of Syrian Arab Republic in 1995 to that in 1996?
Your answer should be compact. 0.84. What is the ratio of the Value added (current US$) in Cuba in 1995 to that in 1997?
Your answer should be very brief. 1.06. What is the ratio of the Value added (current US$) of Ethiopia in 1995 to that in 1997?
Make the answer very short. 0.86. What is the ratio of the Value added (current US$) in Romania in 1995 to that in 1997?
Provide a succinct answer. 1.1. What is the ratio of the Value added (current US$) of Syrian Arab Republic in 1995 to that in 1997?
Your answer should be very brief. 0.86. What is the ratio of the Value added (current US$) of Cuba in 1995 to that in 1998?
Offer a very short reply. 1.15. What is the ratio of the Value added (current US$) in Ethiopia in 1995 to that in 1998?
Give a very brief answer. 1.04. What is the ratio of the Value added (current US$) of Romania in 1995 to that in 1998?
Ensure brevity in your answer.  1.17. What is the ratio of the Value added (current US$) in Syrian Arab Republic in 1995 to that in 1998?
Your answer should be very brief. 0.72. What is the ratio of the Value added (current US$) in Cuba in 1996 to that in 1997?
Provide a succinct answer. 0.98. What is the ratio of the Value added (current US$) of Ethiopia in 1996 to that in 1997?
Your answer should be compact. 0.94. What is the ratio of the Value added (current US$) in Romania in 1996 to that in 1997?
Give a very brief answer. 1.07. What is the ratio of the Value added (current US$) in Syrian Arab Republic in 1996 to that in 1997?
Offer a very short reply. 1.02. What is the ratio of the Value added (current US$) of Cuba in 1996 to that in 1998?
Offer a terse response. 1.07. What is the ratio of the Value added (current US$) of Ethiopia in 1996 to that in 1998?
Provide a succinct answer. 1.14. What is the ratio of the Value added (current US$) of Romania in 1996 to that in 1998?
Your answer should be compact. 1.13. What is the ratio of the Value added (current US$) of Syrian Arab Republic in 1996 to that in 1998?
Your answer should be very brief. 0.86. What is the ratio of the Value added (current US$) of Cuba in 1997 to that in 1998?
Your answer should be compact. 1.09. What is the ratio of the Value added (current US$) of Ethiopia in 1997 to that in 1998?
Ensure brevity in your answer.  1.21. What is the ratio of the Value added (current US$) of Romania in 1997 to that in 1998?
Offer a terse response. 1.06. What is the ratio of the Value added (current US$) of Syrian Arab Republic in 1997 to that in 1998?
Make the answer very short. 0.84. What is the difference between the highest and the second highest Value added (current US$) in Cuba?
Keep it short and to the point. 4.97e+08. What is the difference between the highest and the second highest Value added (current US$) of Ethiopia?
Your answer should be very brief. 1.40e+09. What is the difference between the highest and the second highest Value added (current US$) in Romania?
Your response must be concise. 2.24e+08. What is the difference between the highest and the second highest Value added (current US$) in Syrian Arab Republic?
Offer a terse response. 2.64e+08. What is the difference between the highest and the lowest Value added (current US$) in Cuba?
Your answer should be compact. 9.29e+08. What is the difference between the highest and the lowest Value added (current US$) in Ethiopia?
Your answer should be very brief. 3.05e+09. What is the difference between the highest and the lowest Value added (current US$) in Romania?
Offer a very short reply. 2.24e+09. What is the difference between the highest and the lowest Value added (current US$) in Syrian Arab Republic?
Your answer should be very brief. 1.65e+09. 